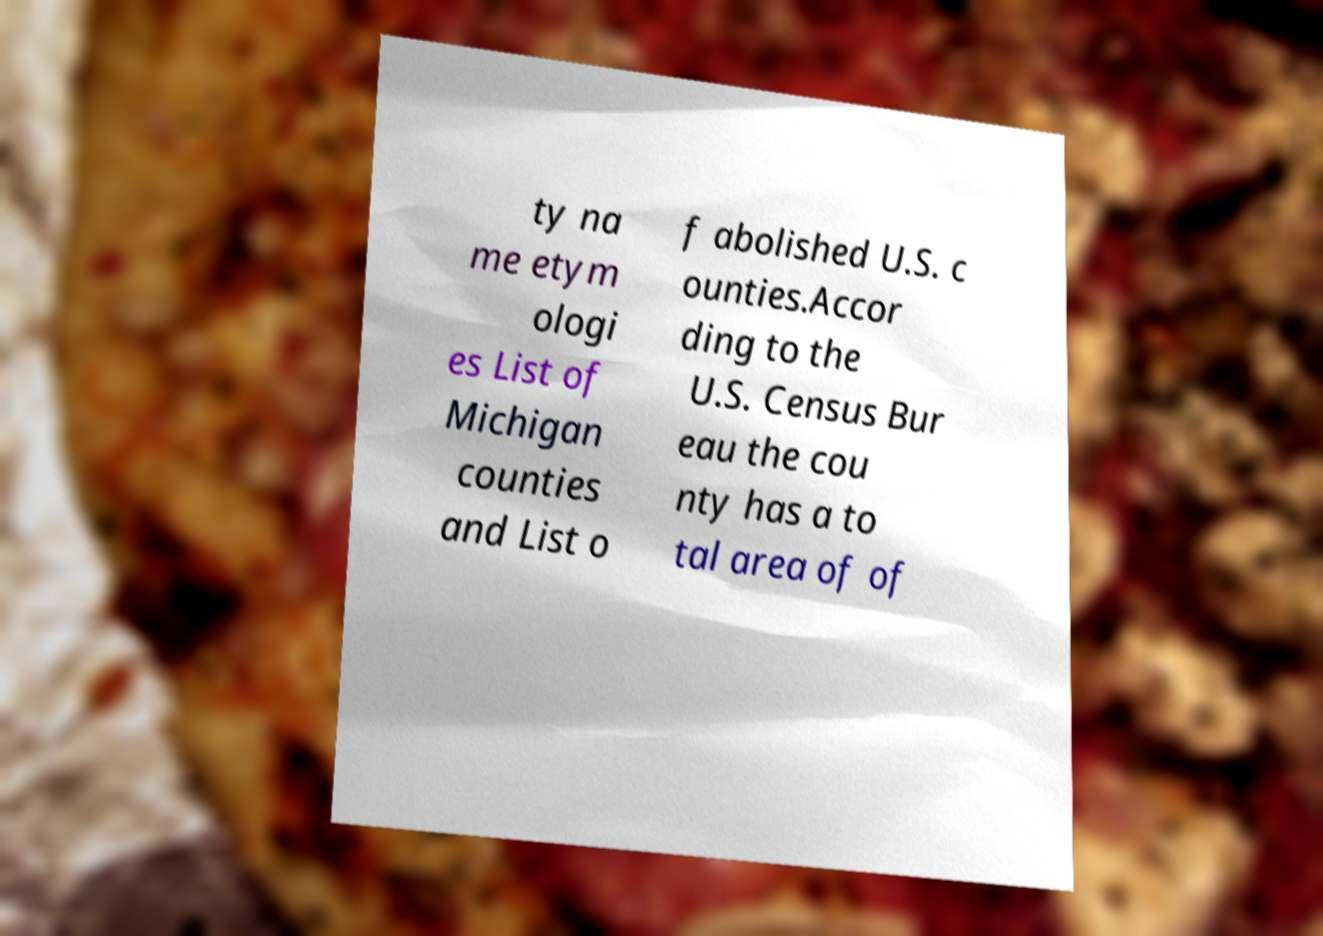I need the written content from this picture converted into text. Can you do that? ty na me etym ologi es List of Michigan counties and List o f abolished U.S. c ounties.Accor ding to the U.S. Census Bur eau the cou nty has a to tal area of of 